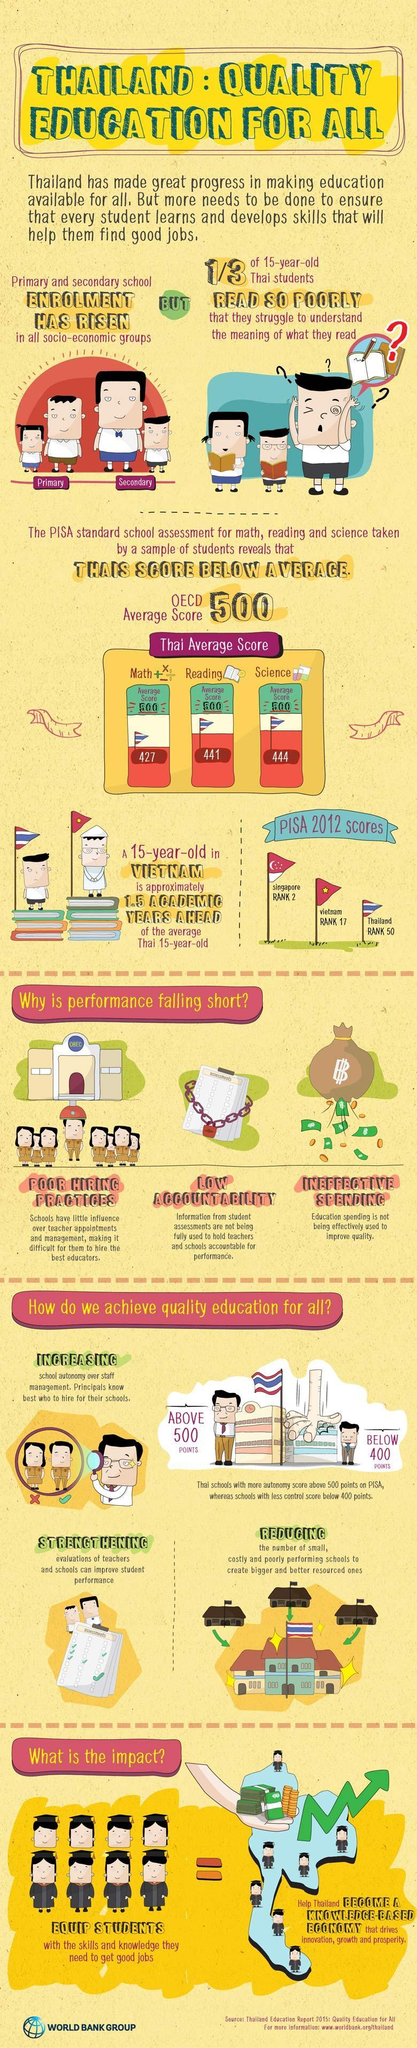What is the Thai average score (out of 500) for science according to the PISA standard school assessment?
Answer the question with a short phrase. 444 What causes a decline in the performance of Thailand's quality education other than poor hiring practices? LOW ACCOUNTABILITY, INEFFECTIVE SPENDING What is the Thai average score (out of 500) for reading according to the PISA standard school assessment? 441 What is the Thai average score (out of 500) for maths according to the PISA standard school assessment? 427 